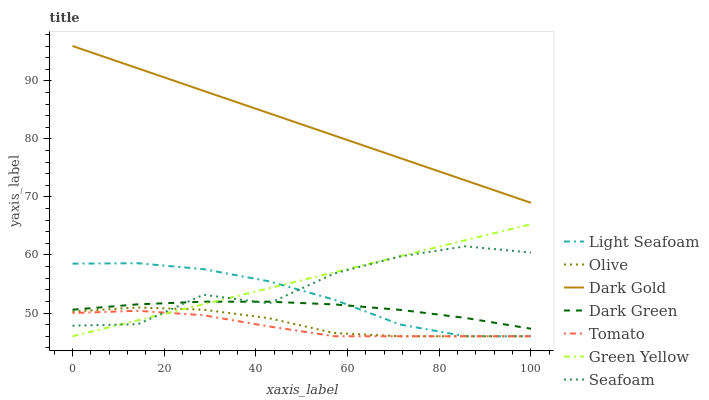Does Tomato have the minimum area under the curve?
Answer yes or no. Yes. Does Dark Gold have the maximum area under the curve?
Answer yes or no. Yes. Does Light Seafoam have the minimum area under the curve?
Answer yes or no. No. Does Light Seafoam have the maximum area under the curve?
Answer yes or no. No. Is Dark Gold the smoothest?
Answer yes or no. Yes. Is Seafoam the roughest?
Answer yes or no. Yes. Is Light Seafoam the smoothest?
Answer yes or no. No. Is Light Seafoam the roughest?
Answer yes or no. No. Does Tomato have the lowest value?
Answer yes or no. Yes. Does Dark Gold have the lowest value?
Answer yes or no. No. Does Dark Gold have the highest value?
Answer yes or no. Yes. Does Light Seafoam have the highest value?
Answer yes or no. No. Is Tomato less than Dark Green?
Answer yes or no. Yes. Is Dark Gold greater than Olive?
Answer yes or no. Yes. Does Light Seafoam intersect Green Yellow?
Answer yes or no. Yes. Is Light Seafoam less than Green Yellow?
Answer yes or no. No. Is Light Seafoam greater than Green Yellow?
Answer yes or no. No. Does Tomato intersect Dark Green?
Answer yes or no. No. 